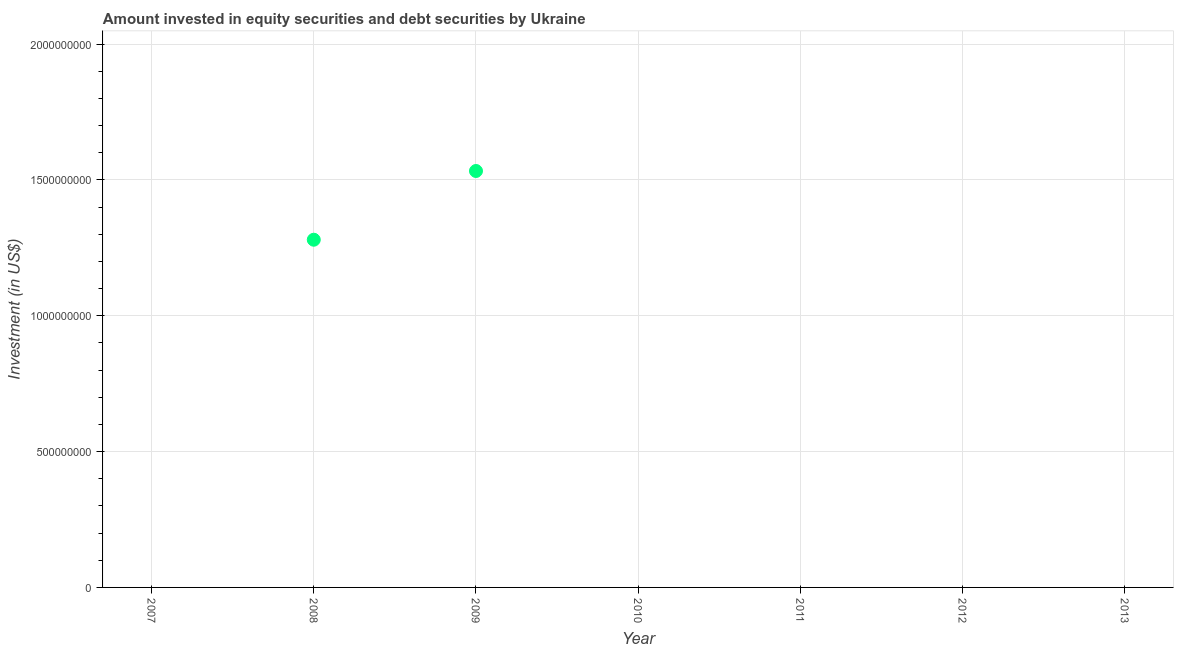Across all years, what is the maximum portfolio investment?
Provide a short and direct response. 1.53e+09. Across all years, what is the minimum portfolio investment?
Offer a very short reply. 0. What is the sum of the portfolio investment?
Give a very brief answer. 2.81e+09. What is the average portfolio investment per year?
Keep it short and to the point. 4.02e+08. What is the median portfolio investment?
Provide a short and direct response. 0. In how many years, is the portfolio investment greater than 1000000000 US$?
Your answer should be compact. 2. What is the difference between the highest and the lowest portfolio investment?
Provide a short and direct response. 1.53e+09. Does the portfolio investment monotonically increase over the years?
Provide a short and direct response. No. How many dotlines are there?
Your answer should be very brief. 1. How many years are there in the graph?
Ensure brevity in your answer.  7. What is the title of the graph?
Your answer should be compact. Amount invested in equity securities and debt securities by Ukraine. What is the label or title of the X-axis?
Your answer should be compact. Year. What is the label or title of the Y-axis?
Your answer should be very brief. Investment (in US$). What is the Investment (in US$) in 2007?
Keep it short and to the point. 0. What is the Investment (in US$) in 2008?
Your answer should be very brief. 1.28e+09. What is the Investment (in US$) in 2009?
Offer a terse response. 1.53e+09. What is the Investment (in US$) in 2010?
Give a very brief answer. 0. What is the Investment (in US$) in 2011?
Keep it short and to the point. 0. What is the difference between the Investment (in US$) in 2008 and 2009?
Ensure brevity in your answer.  -2.53e+08. What is the ratio of the Investment (in US$) in 2008 to that in 2009?
Give a very brief answer. 0.83. 